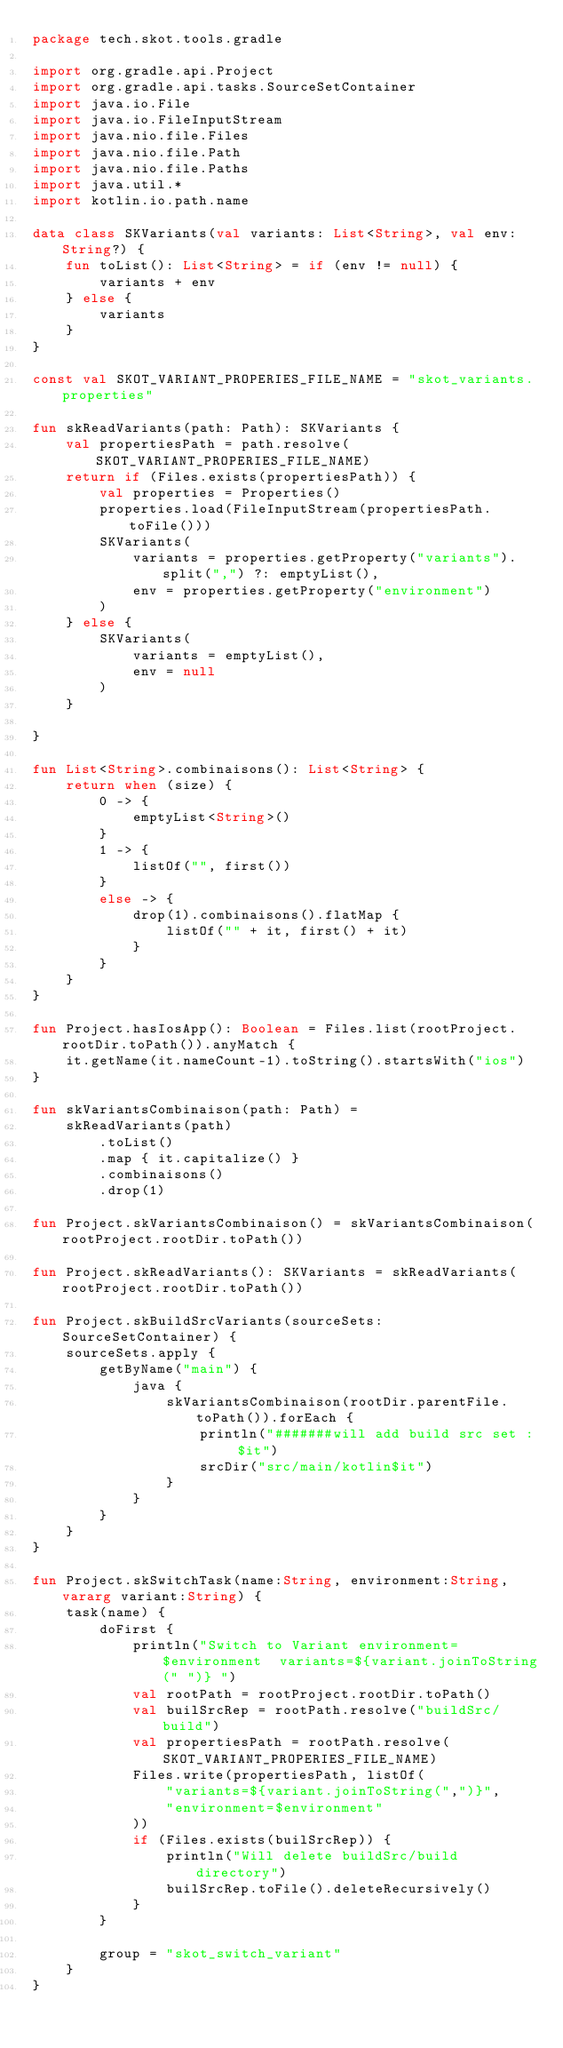Convert code to text. <code><loc_0><loc_0><loc_500><loc_500><_Kotlin_>package tech.skot.tools.gradle

import org.gradle.api.Project
import org.gradle.api.tasks.SourceSetContainer
import java.io.File
import java.io.FileInputStream
import java.nio.file.Files
import java.nio.file.Path
import java.nio.file.Paths
import java.util.*
import kotlin.io.path.name

data class SKVariants(val variants: List<String>, val env: String?) {
    fun toList(): List<String> = if (env != null) {
        variants + env
    } else {
        variants
    }
}

const val SKOT_VARIANT_PROPERIES_FILE_NAME = "skot_variants.properties"

fun skReadVariants(path: Path): SKVariants {
    val propertiesPath = path.resolve(SKOT_VARIANT_PROPERIES_FILE_NAME)
    return if (Files.exists(propertiesPath)) {
        val properties = Properties()
        properties.load(FileInputStream(propertiesPath.toFile()))
        SKVariants(
            variants = properties.getProperty("variants").split(",") ?: emptyList(),
            env = properties.getProperty("environment")
        )
    } else {
        SKVariants(
            variants = emptyList(),
            env = null
        )
    }

}

fun List<String>.combinaisons(): List<String> {
    return when (size) {
        0 -> {
            emptyList<String>()
        }
        1 -> {
            listOf("", first())
        }
        else -> {
            drop(1).combinaisons().flatMap {
                listOf("" + it, first() + it)
            }
        }
    }
}

fun Project.hasIosApp(): Boolean = Files.list(rootProject.rootDir.toPath()).anyMatch {
    it.getName(it.nameCount-1).toString().startsWith("ios")
}

fun skVariantsCombinaison(path: Path) =
    skReadVariants(path)
        .toList()
        .map { it.capitalize() }
        .combinaisons()
        .drop(1)

fun Project.skVariantsCombinaison() = skVariantsCombinaison(rootProject.rootDir.toPath())

fun Project.skReadVariants(): SKVariants = skReadVariants(rootProject.rootDir.toPath())

fun Project.skBuildSrcVariants(sourceSets: SourceSetContainer) {
    sourceSets.apply {
        getByName("main") {
            java {
                skVariantsCombinaison(rootDir.parentFile.toPath()).forEach {
                    println("#######will add build src set : $it")
                    srcDir("src/main/kotlin$it")
                }
            }
        }
    }
}

fun Project.skSwitchTask(name:String, environment:String, vararg variant:String) {
    task(name) {
        doFirst {
            println("Switch to Variant environment=$environment  variants=${variant.joinToString(" ")} ")
            val rootPath = rootProject.rootDir.toPath()
            val builSrcRep = rootPath.resolve("buildSrc/build")
            val propertiesPath = rootPath.resolve(SKOT_VARIANT_PROPERIES_FILE_NAME)
            Files.write(propertiesPath, listOf(
                "variants=${variant.joinToString(",")}",
                "environment=$environment"
            ))
            if (Files.exists(builSrcRep)) {
                println("Will delete buildSrc/build directory")
                builSrcRep.toFile().deleteRecursively()
            }
        }

        group = "skot_switch_variant"
    }
}</code> 